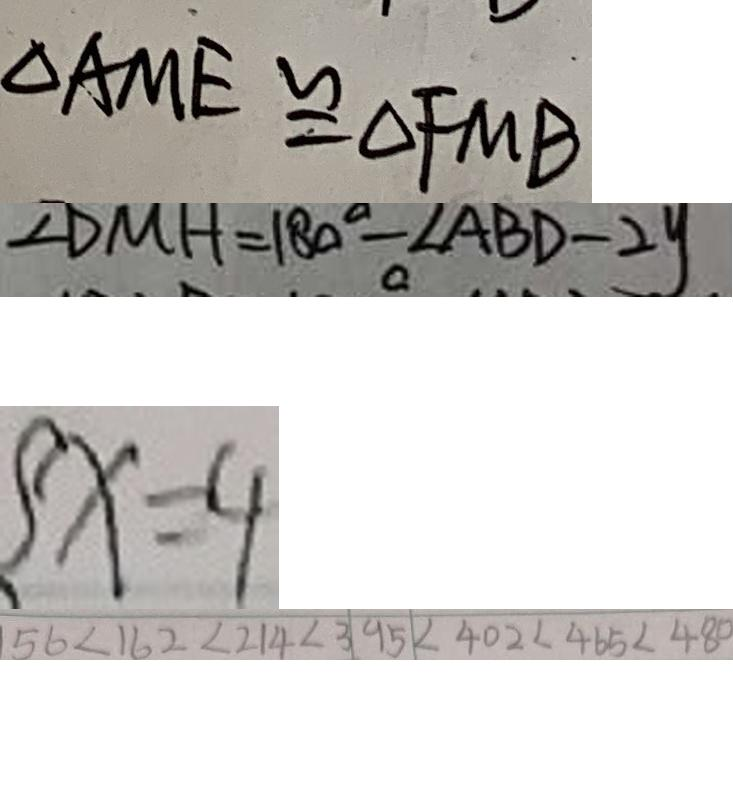<formula> <loc_0><loc_0><loc_500><loc_500>\Delta A M E \cong \Delta F M B 
 \angle D M H = 1 8 0 ^ { \circ } - \angle A B D - 2 y 
 \{ x = 4 
 5 6 < 1 6 2 < 2 1 4 < 3 9 5 < 4 0 2 < 4 6 5 < 4 8 0</formula> 